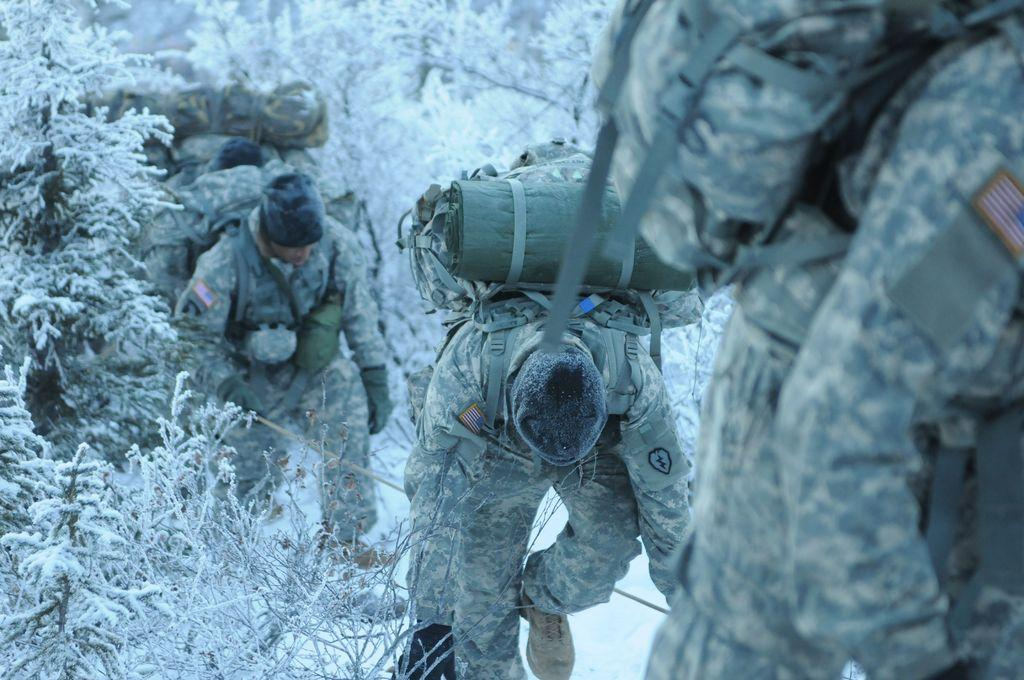What can be seen in the image? There are persons standing in the image. What are the persons holding? The persons are holding backpacks. What is visible in the background of the image? There are trees in the background of the image. What type of texture can be seen on the beetle's shell in the image? There is no beetle present in the image, so it is not possible to determine the texture of its shell. 